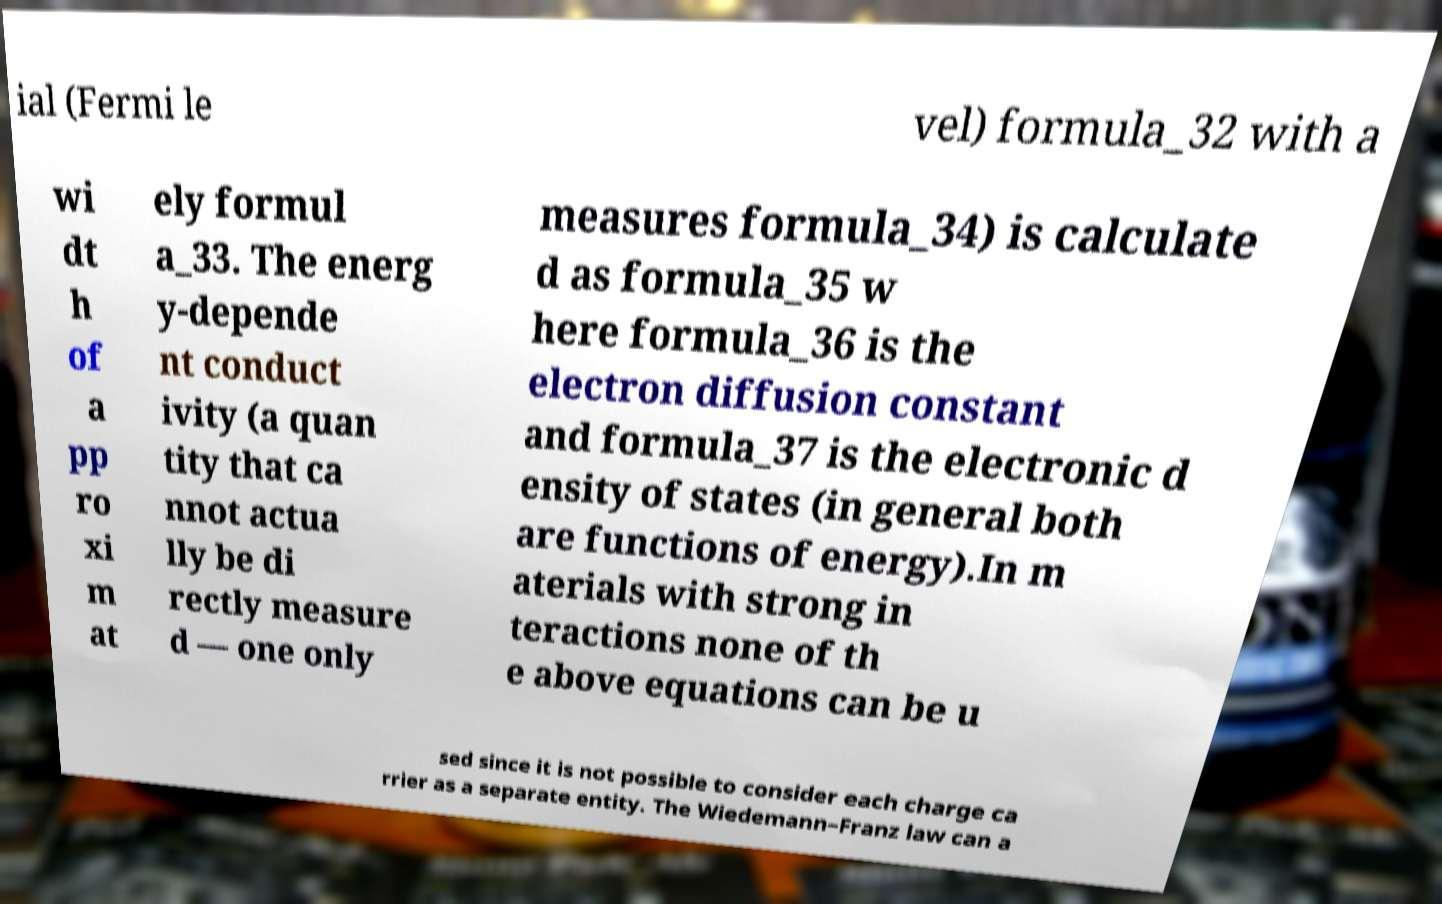For documentation purposes, I need the text within this image transcribed. Could you provide that? ial (Fermi le vel) formula_32 with a wi dt h of a pp ro xi m at ely formul a_33. The energ y-depende nt conduct ivity (a quan tity that ca nnot actua lly be di rectly measure d — one only measures formula_34) is calculate d as formula_35 w here formula_36 is the electron diffusion constant and formula_37 is the electronic d ensity of states (in general both are functions of energy).In m aterials with strong in teractions none of th e above equations can be u sed since it is not possible to consider each charge ca rrier as a separate entity. The Wiedemann–Franz law can a 